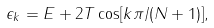<formula> <loc_0><loc_0><loc_500><loc_500>\epsilon _ { k } = E + 2 T \cos [ k \pi / ( N + 1 ) ] ,</formula> 